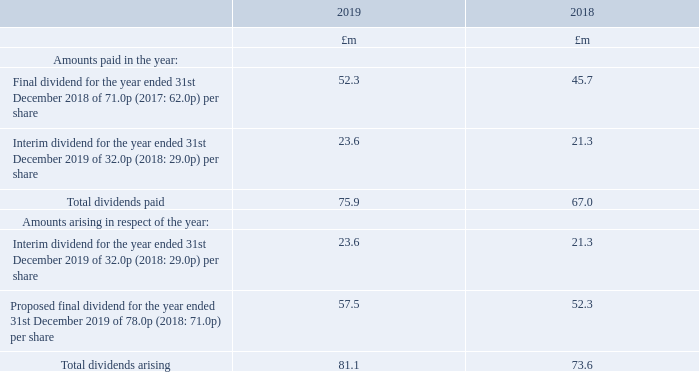11 Dividends
The proposed dividend is subject to approval in 2020. It is therefore not included as a liability in these Financial Statements. No scrip alternative to the cash dividend is being offered in respect of the proposed final dividend for the year ended 31st December 2019.
What is the Total dividends paid for 2019?
Answer scale should be: million. 75.9. When is the proposed dividend subject to be approved? 2020. For which years are the amounts of total dividends paid calculated? 2019, 2018. In which year was the total dividends paid larger? 75.9>67.0
Answer: 2019. What was the change in the amount of total dividends paid in 2019 from 2018?
Answer scale should be: million. 75.9-67.0
Answer: 8.9. What was the percentage change in the amount of total dividends paid in 2019 from 2018?
Answer scale should be: percent. (75.9-67.0)/67.0
Answer: 13.28. 